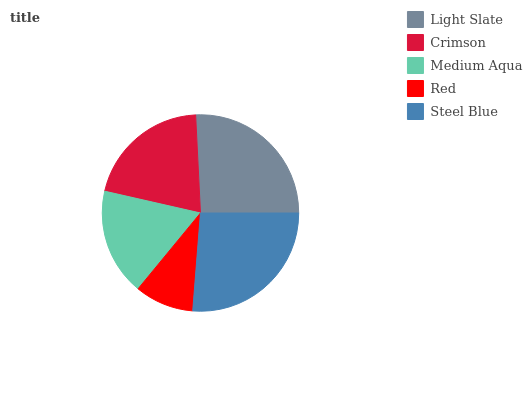Is Red the minimum?
Answer yes or no. Yes. Is Steel Blue the maximum?
Answer yes or no. Yes. Is Crimson the minimum?
Answer yes or no. No. Is Crimson the maximum?
Answer yes or no. No. Is Light Slate greater than Crimson?
Answer yes or no. Yes. Is Crimson less than Light Slate?
Answer yes or no. Yes. Is Crimson greater than Light Slate?
Answer yes or no. No. Is Light Slate less than Crimson?
Answer yes or no. No. Is Crimson the high median?
Answer yes or no. Yes. Is Crimson the low median?
Answer yes or no. Yes. Is Light Slate the high median?
Answer yes or no. No. Is Steel Blue the low median?
Answer yes or no. No. 